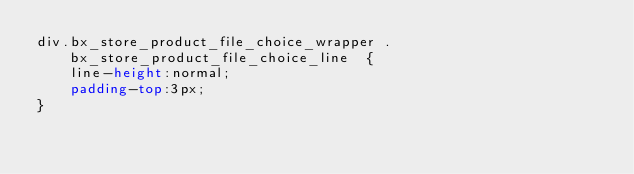Convert code to text. <code><loc_0><loc_0><loc_500><loc_500><_CSS_>div.bx_store_product_file_choice_wrapper .bx_store_product_file_choice_line  {
    line-height:normal;
    padding-top:3px;
}
</code> 